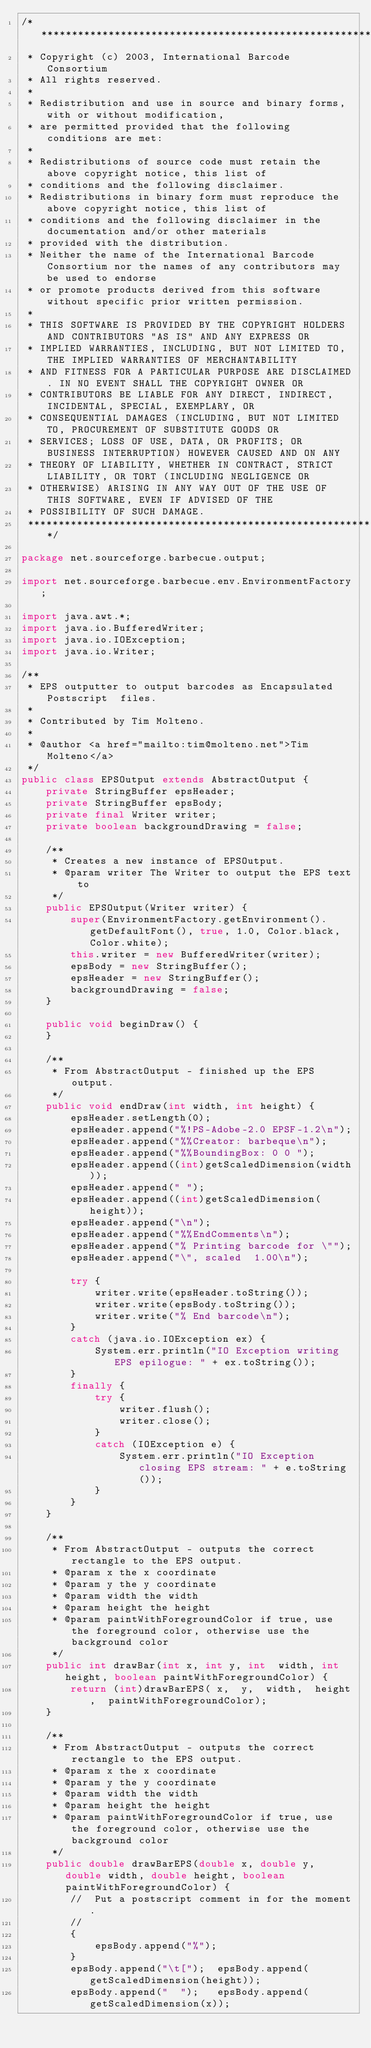<code> <loc_0><loc_0><loc_500><loc_500><_Java_>/***********************************************************************************************************************
 * Copyright (c) 2003, International Barcode Consortium
 * All rights reserved.
 *
 * Redistribution and use in source and binary forms, with or without modification,
 * are permitted provided that the following conditions are met:
 *
 * Redistributions of source code must retain the above copyright notice, this list of
 * conditions and the following disclaimer.
 * Redistributions in binary form must reproduce the above copyright notice, this list of
 * conditions and the following disclaimer in the documentation and/or other materials
 * provided with the distribution.
 * Neither the name of the International Barcode Consortium nor the names of any contributors may be used to endorse
 * or promote products derived from this software without specific prior written permission.
 *
 * THIS SOFTWARE IS PROVIDED BY THE COPYRIGHT HOLDERS AND CONTRIBUTORS "AS IS" AND ANY EXPRESS OR
 * IMPLIED WARRANTIES, INCLUDING, BUT NOT LIMITED TO, THE IMPLIED WARRANTIES OF MERCHANTABILITY
 * AND FITNESS FOR A PARTICULAR PURPOSE ARE DISCLAIMED. IN NO EVENT SHALL THE COPYRIGHT OWNER OR
 * CONTRIBUTORS BE LIABLE FOR ANY DIRECT, INDIRECT, INCIDENTAL, SPECIAL, EXEMPLARY, OR
 * CONSEQUENTIAL DAMAGES (INCLUDING, BUT NOT LIMITED TO, PROCUREMENT OF SUBSTITUTE GOODS OR
 * SERVICES; LOSS OF USE, DATA, OR PROFITS; OR BUSINESS INTERRUPTION) HOWEVER CAUSED AND ON ANY
 * THEORY OF LIABILITY, WHETHER IN CONTRACT, STRICT LIABILITY, OR TORT (INCLUDING NEGLIGENCE OR
 * OTHERWISE) ARISING IN ANY WAY OUT OF THE USE OF THIS SOFTWARE, EVEN IF ADVISED OF THE
 * POSSIBILITY OF SUCH DAMAGE.
 ***********************************************************************************************************************/

package net.sourceforge.barbecue.output;

import net.sourceforge.barbecue.env.EnvironmentFactory;

import java.awt.*;
import java.io.BufferedWriter;
import java.io.IOException;
import java.io.Writer;

/**
 * EPS outputter to output barcodes as Encapsulated Postscript  files.
 *
 * Contributed by Tim Molteno.
 *
 * @author <a href="mailto:tim@molteno.net">Tim Molteno</a>
 */
public class EPSOutput extends AbstractOutput {
    private StringBuffer epsHeader;
    private StringBuffer epsBody;
    private final Writer writer;
    private boolean backgroundDrawing = false;
    
    /**
     * Creates a new instance of EPSOutput.
     * @param writer The Writer to output the EPS text to
     */
    public EPSOutput(Writer writer) {
        super(EnvironmentFactory.getEnvironment().getDefaultFont(), true, 1.0, Color.black, Color.white);
        this.writer = new BufferedWriter(writer);
        epsBody = new StringBuffer();
        epsHeader = new StringBuffer();
        backgroundDrawing = false;
    }
    
    public void beginDraw() {
    }
    
    /**
     * From AbstractOutput - finished up the EPS output.
     */
    public void endDraw(int width, int height) {
        epsHeader.setLength(0);
        epsHeader.append("%!PS-Adobe-2.0 EPSF-1.2\n");
        epsHeader.append("%%Creator: barbeque\n");
        epsHeader.append("%%BoundingBox: 0 0 ");
        epsHeader.append((int)getScaledDimension(width));
        epsHeader.append(" ");
        epsHeader.append((int)getScaledDimension(height));
        epsHeader.append("\n");
        epsHeader.append("%%EndComments\n");
        epsHeader.append("% Printing barcode for \"");
        epsHeader.append("\", scaled  1.00\n");
        
        try {
            writer.write(epsHeader.toString());
            writer.write(epsBody.toString());
            writer.write("% End barcode\n");
        }
        catch (java.io.IOException ex) {
            System.err.println("IO Exception writing EPS epilogue: " + ex.toString());
        }
        finally {
            try {
                writer.flush();
                writer.close();
            }
            catch (IOException e) {
                System.err.println("IO Exception closing EPS stream: " + e.toString());
            }
        }
    }
    
    /**
     * From AbstractOutput - outputs the correct rectangle to the EPS output.
     * @param x the x coordinate
     * @param y the y coordinate
     * @param width the width
     * @param height the height
     * @param paintWithForegroundColor if true, use the foreground color, otherwise use the background color
     */
    public int drawBar(int x, int y, int  width, int height, boolean paintWithForegroundColor) {
        return (int)drawBarEPS( x,  y,  width,  height,  paintWithForegroundColor);
    }
    
    /**
     * From AbstractOutput - outputs the correct rectangle to the EPS output.
     * @param x the x coordinate
     * @param y the y coordinate
     * @param width the width
     * @param height the height
     * @param paintWithForegroundColor if true, use the foreground color, otherwise use the background color
     */
    public double drawBarEPS(double x, double y, double width, double height, boolean paintWithForegroundColor) {
        //	Put a postscript comment in for the moment.
        //
        {
            epsBody.append("%");
        }
        epsBody.append("\t["); 	epsBody.append(getScaledDimension(height));
        epsBody.append("  "); 	epsBody.append(getScaledDimension(x));</code> 